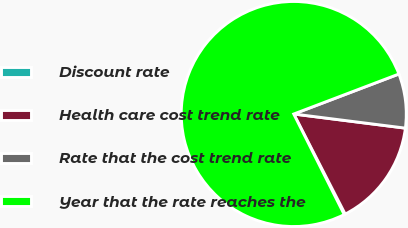Convert chart to OTSL. <chart><loc_0><loc_0><loc_500><loc_500><pie_chart><fcel>Discount rate<fcel>Health care cost trend rate<fcel>Rate that the cost trend rate<fcel>Year that the rate reaches the<nl><fcel>0.15%<fcel>15.44%<fcel>7.79%<fcel>76.62%<nl></chart> 